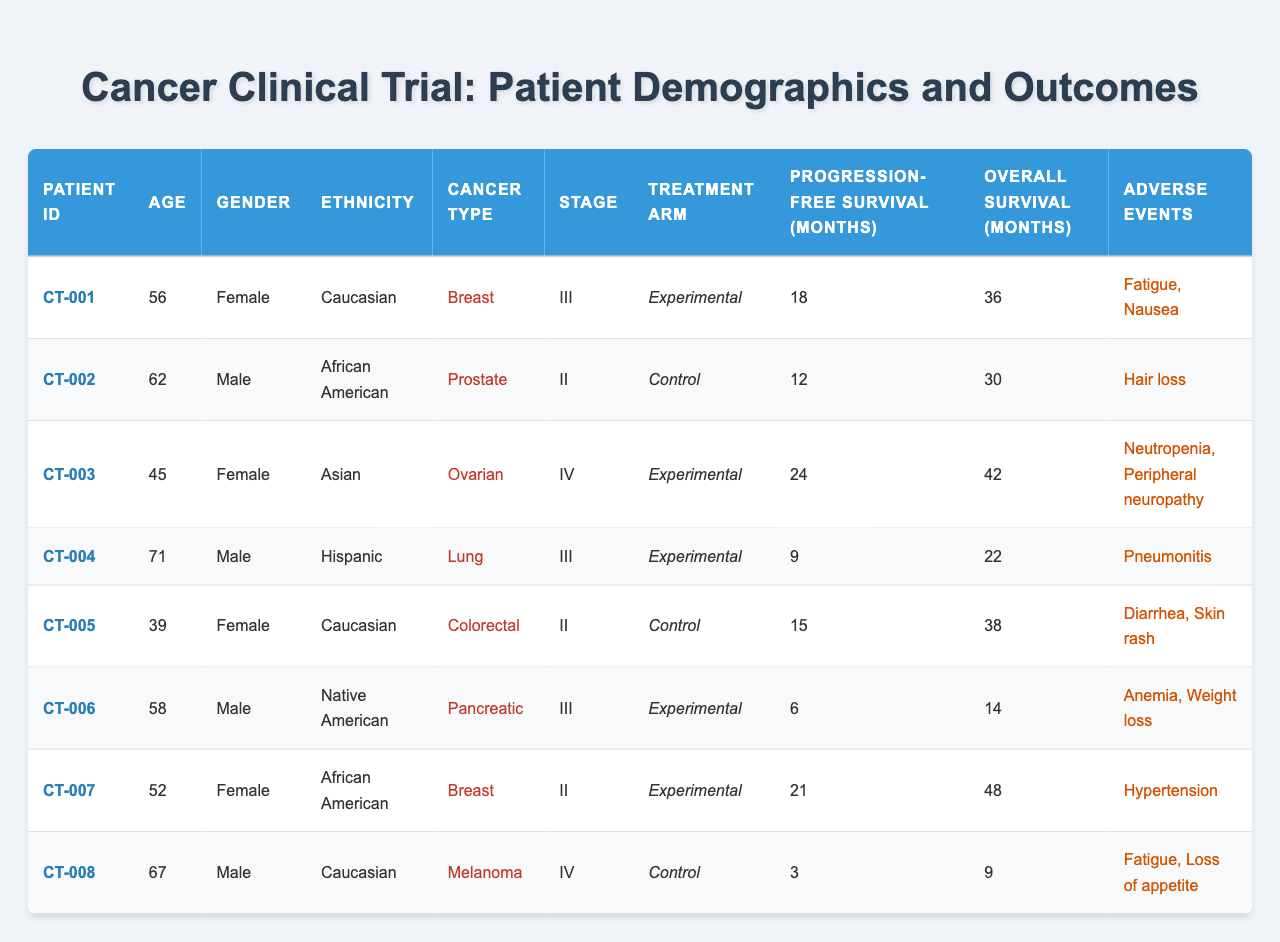What is the age of patient CT-005? The table lists the demographic information including age for each patient. For patient CT-005, the age is directly specified as 39.
Answer: 39 In which treatment arm is patient CT-006 enrolled? The treatment arm is indicated directly in the table under the "Treatment Arm" column. Patient CT-006 is enrolled in the "Experimental" arm.
Answer: Experimental How many patients experienced adverse events? By counting the number of patients listed in the table, we see that every patient has listed at least one adverse event, totaling eight patients.
Answer: 8 What is the overall survival duration of patient CT-002? The overall survival duration is provided in the table under the "Overall Survival (Months)" column. For patient CT-002, it is stated as 30 months.
Answer: 30 months What is the average progression-free survival for patients in the Experimental treatment arm? First, identify the patients in the Experimental arm: CT-001, CT-003, CT-004, CT-006, and CT-007, with their progression-free months being 18, 24, 9, 6, and 21 respectively. Sum these values: 18 + 24 + 9 + 6 + 21 = 78. Divide by the 5 patients to get the average: 78 / 5 = 15.6 months.
Answer: 15.6 months Is patient CT-008 a female? The table specifies the gender of each patient. For patient CT-008, the gender is indicated as "Male." Therefore, patient CT-008 is not female.
Answer: No Which cancer type has the most patients receiving the Experimental treatment? The table lists the cancer types of patients in the Experimental arm: CT-001 (Breast), CT-003 (Ovarian), CT-004 (Lung), CT-006 (Pancreatic), and CT-007 (Breast). The Breast cancer type appears for both CT-001 and CT-007, totaling two patients, which is more than other types.
Answer: Breast What is the median age of all patients? List the ages of all patients: 56, 62, 45, 71, 39, 58, 52, and 67. Arranging them in order gives: 39, 45, 52, 56, 58, 62, 67, 71. Since there are 8 patients, the median is the average of the 4th and 5th values: (56 + 58) / 2 = 57.
Answer: 57 How many patients experienced "Fatigue" as an adverse event? The adverse events for each patient are summarized in the table. Patient CT-001 and CT-008 have "Fatigue" listed as an adverse event. That totals two patients experiencing "Fatigue."
Answer: 2 What is the overall survival range (difference) between CT-003 and CT-004? On the table, CT-003 has an overall survival of 42 months, and CT-004 has 22 months. To find the range, subtract: 42 - 22 = 20 months.
Answer: 20 months How many patients had a cancer type listed as stage III? By checking the "Stage" column for each patient, CT-001, CT-004, and CT-006 are in stage III, totaling three patients.
Answer: 3 